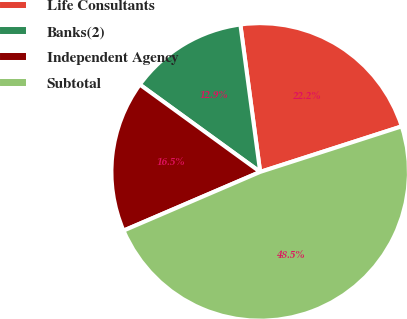Convert chart. <chart><loc_0><loc_0><loc_500><loc_500><pie_chart><fcel>Life Consultants<fcel>Banks(2)<fcel>Independent Agency<fcel>Subtotal<nl><fcel>22.17%<fcel>12.88%<fcel>16.45%<fcel>48.5%<nl></chart> 